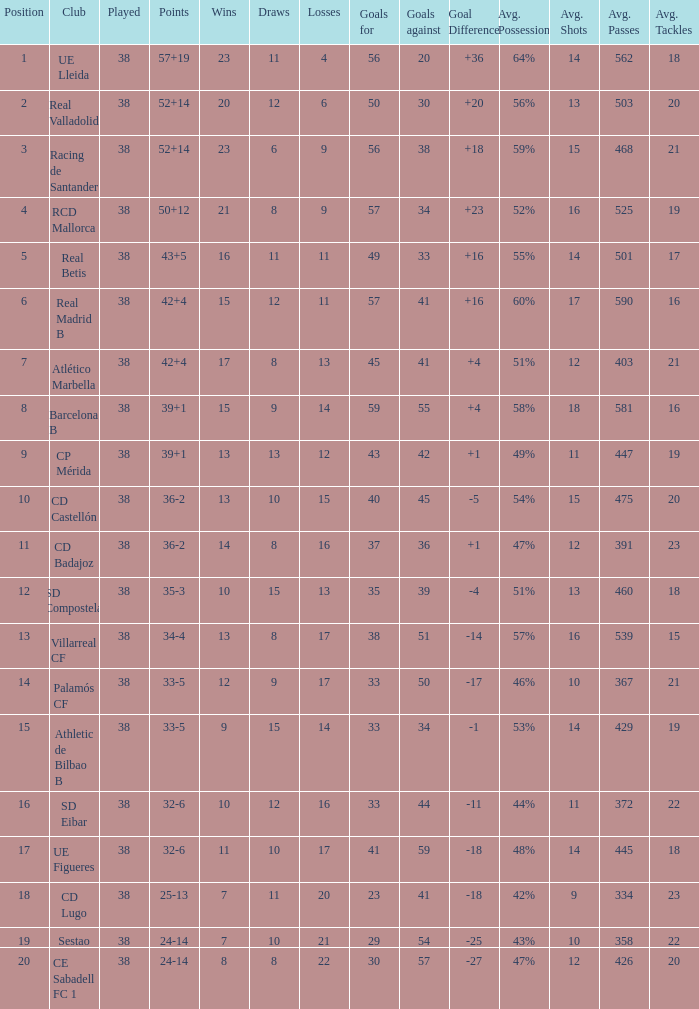What is the lowest position with 32-6 points and less then 59 goals when there are more than 38 played? None. 